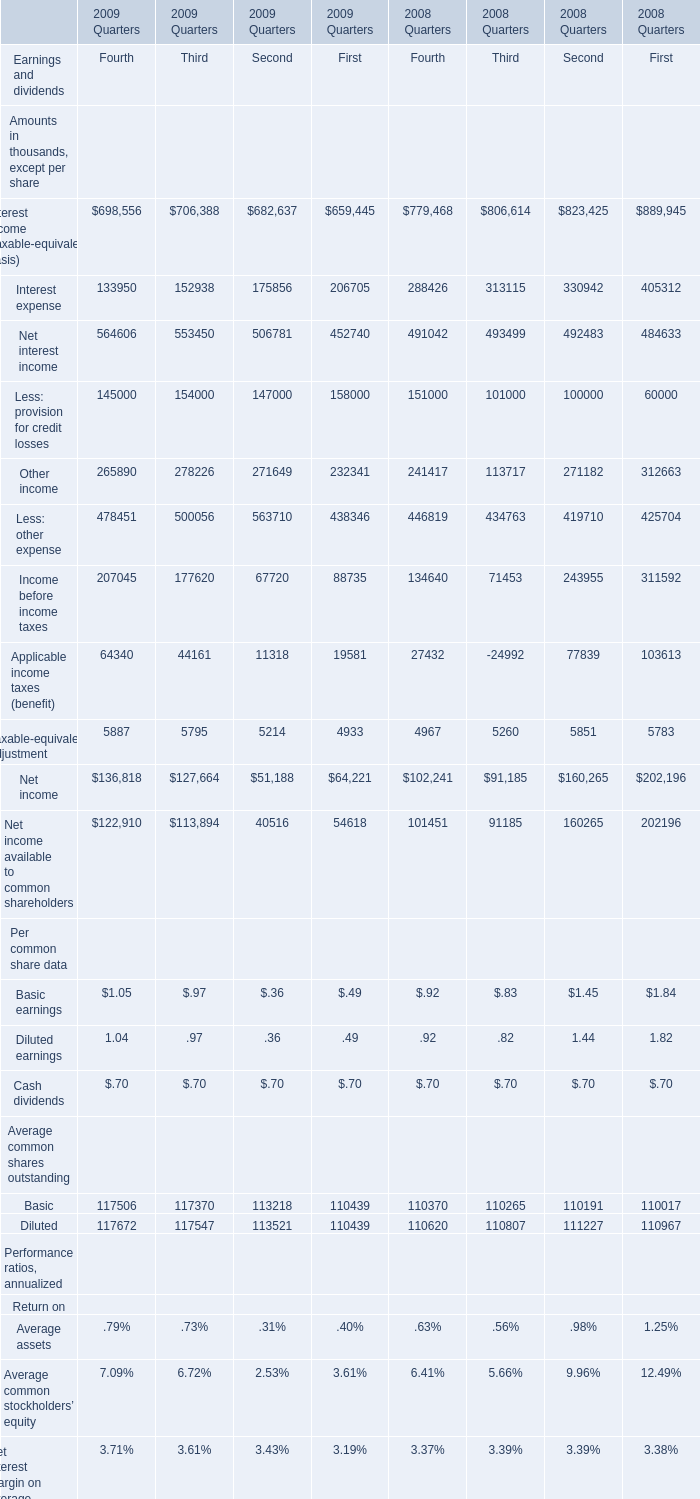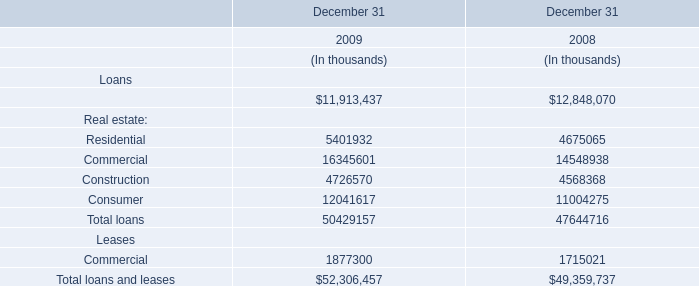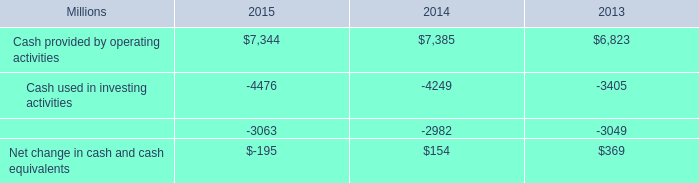In the year with lowest amount of Other income for First, what's the increasing rate of Less: other expense? 
Computations: ((438346 - 425704) / 425704)
Answer: 0.0297. 